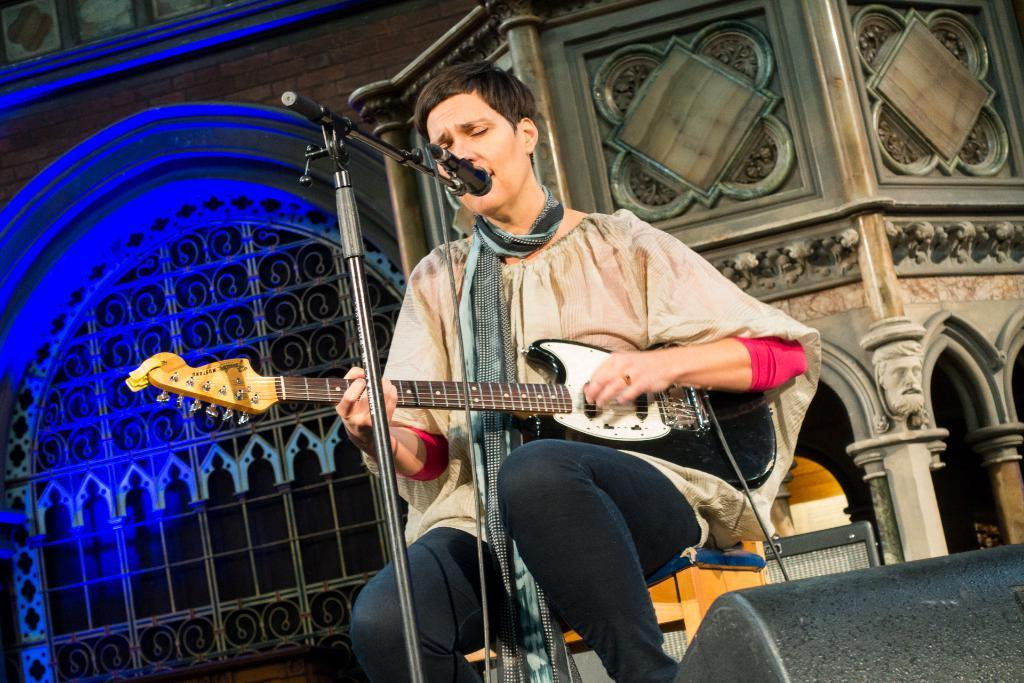What is the main subject of the image? There is a person in the image. What type of clothing is the person wearing? The person is wearing black jeans. What activity is the person engaged in? The person is singing and playing a guitar. What object is present to amplify the person's voice? There is a microphone in the image. Can you tell me the size of the baby's brain in the image? There is no baby present in the image, so it is not possible to determine the size of a baby's brain. 